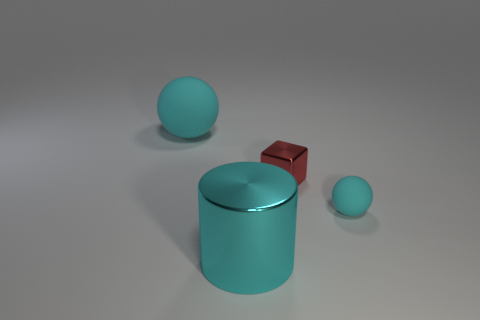There is a object that is the same material as the tiny cube; what shape is it?
Make the answer very short. Cylinder. What number of matte objects are small cubes or big red cylinders?
Your response must be concise. 0. What number of cyan rubber things are behind the cyan sphere to the right of the cyan matte object that is behind the red metal thing?
Keep it short and to the point. 1. Is the size of the rubber thing to the right of the cyan metal object the same as the shiny thing that is behind the big cyan metallic cylinder?
Provide a succinct answer. Yes. What material is the tiny cyan thing that is the same shape as the big cyan rubber thing?
Your answer should be compact. Rubber. What number of big things are either red shiny things or cyan objects?
Your response must be concise. 2. What material is the small sphere?
Your answer should be very brief. Rubber. There is a thing that is both in front of the tiny red shiny object and right of the large metal cylinder; what material is it made of?
Give a very brief answer. Rubber. Do the large metal object and the big object that is behind the shiny cylinder have the same color?
Give a very brief answer. Yes. There is a sphere that is the same size as the cyan metallic object; what is it made of?
Offer a very short reply. Rubber. 